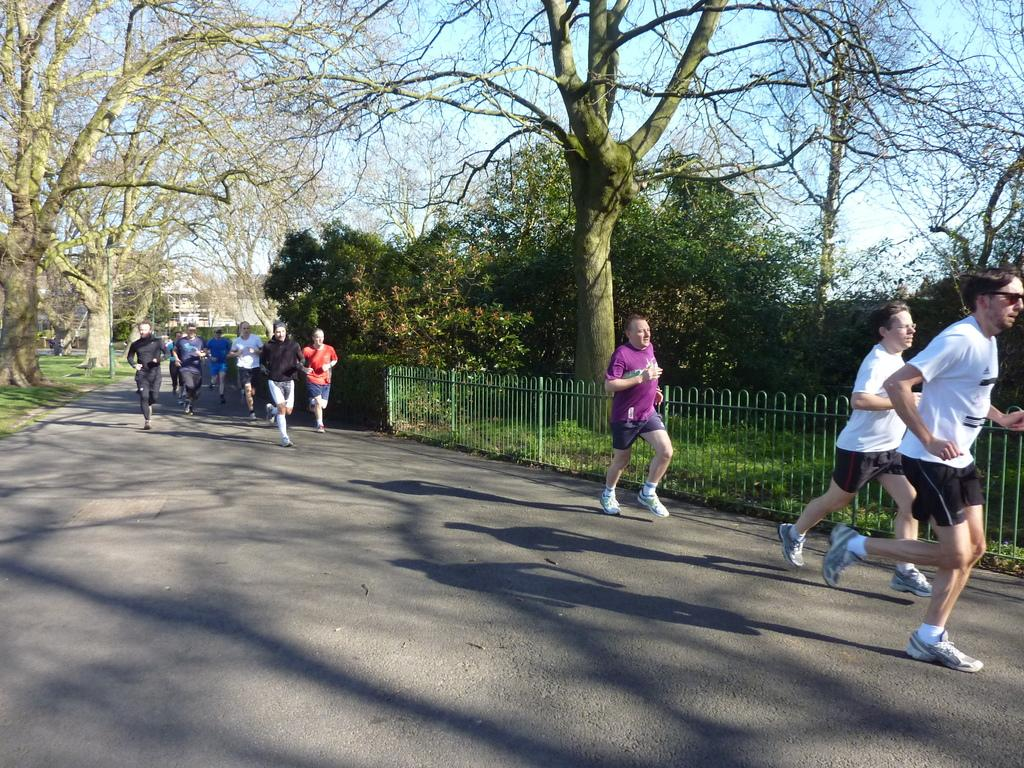What are the people in the image doing? The people in the image are running on the road. What can be seen in the background of the image? There are trees, plants, a pole, a fence, grass, and the sky visible in the background of the image. What type of cub is attempting to sing in the image? There is no cub present in the image, nor is there any indication of an attempt to sing. 